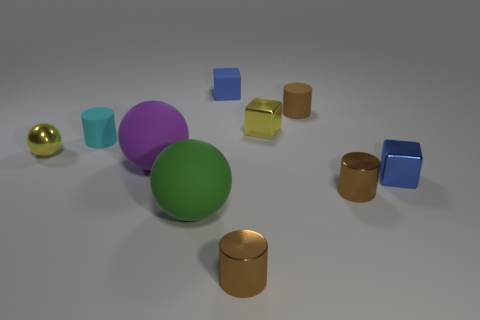How is the lighting affecting the appearance of the objects? The lighting creates subtle shadows on the ground, emphasizing the three-dimensionality of the objects. It also enhances the visual textures of each material, particularly accentuating the shiny surfaces of the metallic objects by creating bright specular highlights. Can you tell the time of day just by looking at the image based on the lighting? The time of day cannot be inferred as this scene appears to be artificially lit, suggesting an indoor setup with controlled lighting, rather than natural outdoor lighting. 